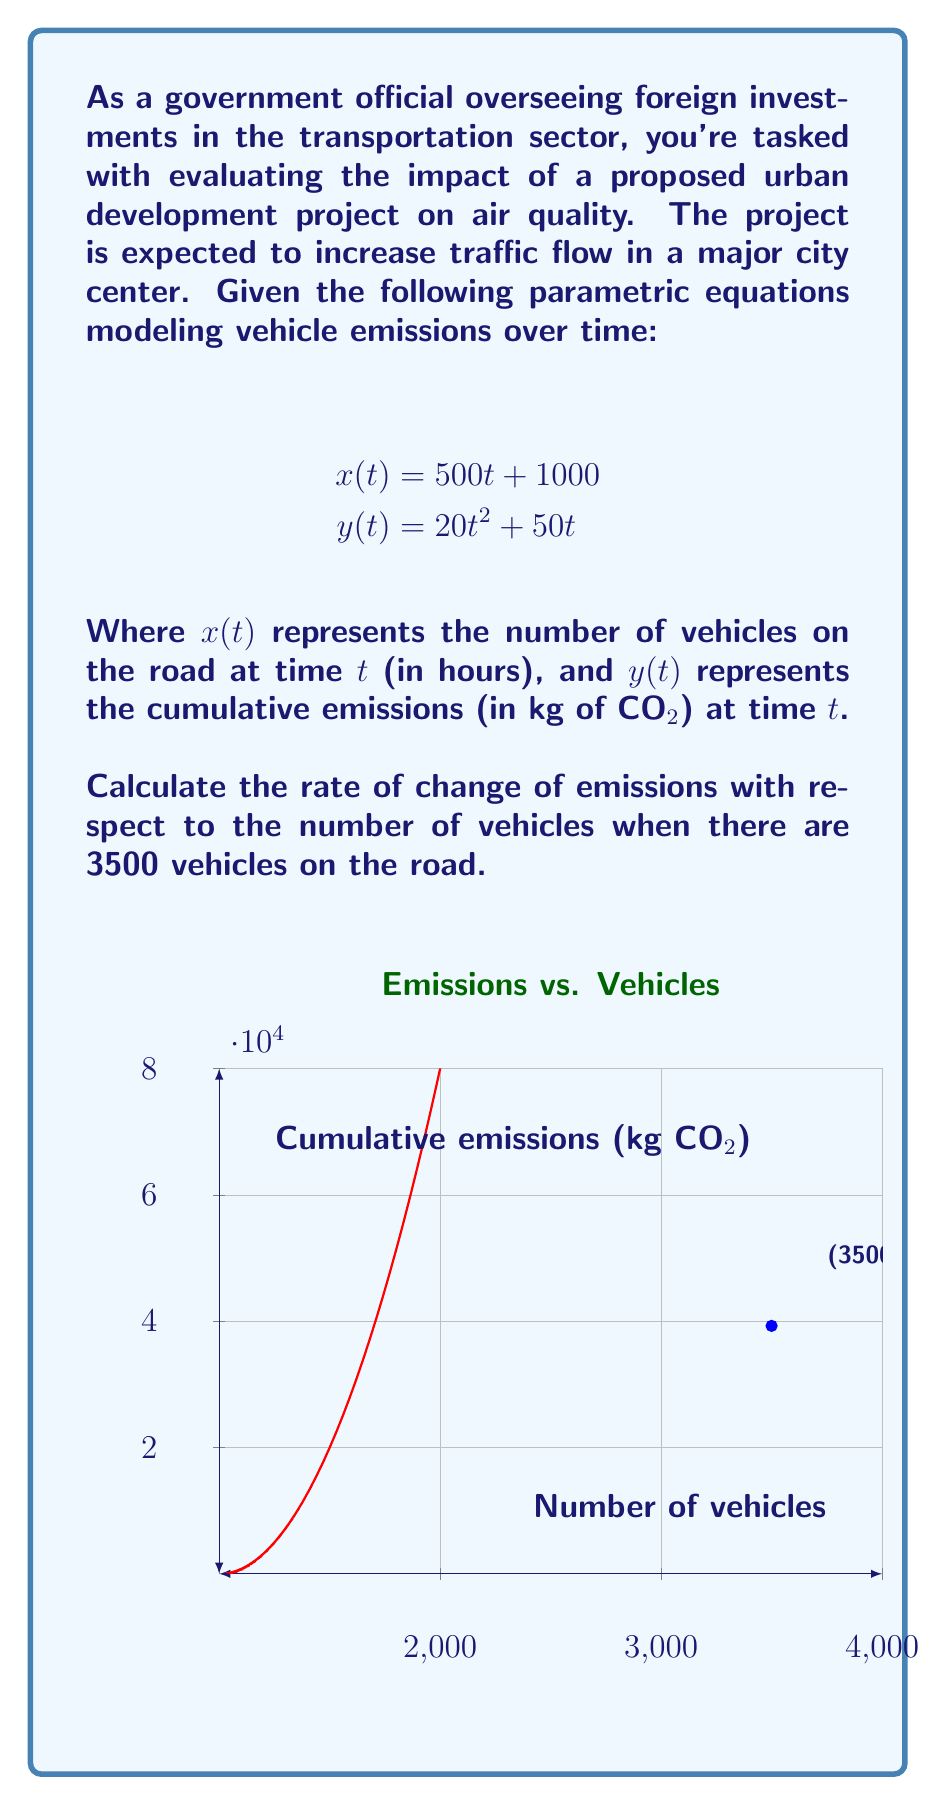Teach me how to tackle this problem. Let's approach this step-by-step:

1) First, we need to find the time $t$ when there are 3500 vehicles on the road. We can use the equation for $x(t)$:

   $$3500 = 500t + 1000$$

2) Solving for $t$:
   $$2500 = 500t$$
   $$t = 5$$

3) Now that we know $t = 5$, we can find $\frac{dy}{dt}$ and $\frac{dx}{dt}$ at this time:

   $$\frac{dy}{dt} = 40t + 50$$
   $$\frac{dy}{dt}|_{t=5} = 40(5) + 50 = 250$$

   $$\frac{dx}{dt} = 500$$ (this is constant)

4) The rate of change of emissions with respect to the number of vehicles is given by:

   $$\frac{dy}{dx} = \frac{dy/dt}{dx/dt}$$

5) Substituting our values:

   $$\frac{dy}{dx} = \frac{250}{500} = 0.5$$

Therefore, when there are 3500 vehicles on the road, the rate of change of emissions with respect to the number of vehicles is 0.5 kg of CO₂ per vehicle.
Answer: 0.5 kg CO₂/vehicle 